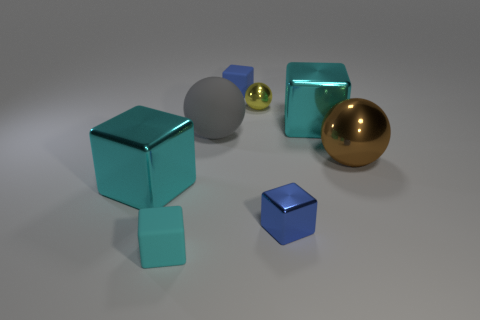What number of objects are either large blue rubber blocks or shiny spheres that are left of the blue shiny object?
Your answer should be compact. 1. What is the material of the yellow thing that is the same size as the cyan rubber object?
Offer a terse response. Metal. Is the gray sphere made of the same material as the tiny cyan thing?
Make the answer very short. Yes. What is the color of the thing that is behind the brown metal object and on the left side of the small blue rubber object?
Provide a succinct answer. Gray. Does the large block that is left of the yellow thing have the same color as the rubber ball?
Provide a short and direct response. No. What shape is the gray rubber object that is the same size as the brown ball?
Make the answer very short. Sphere. What number of other things are the same color as the small shiny block?
Your answer should be compact. 1. How many other things are made of the same material as the big brown sphere?
Give a very brief answer. 4. There is a blue shiny cube; does it have the same size as the cyan shiny cube left of the small cyan object?
Ensure brevity in your answer.  No. What color is the large metallic sphere?
Your response must be concise. Brown. 